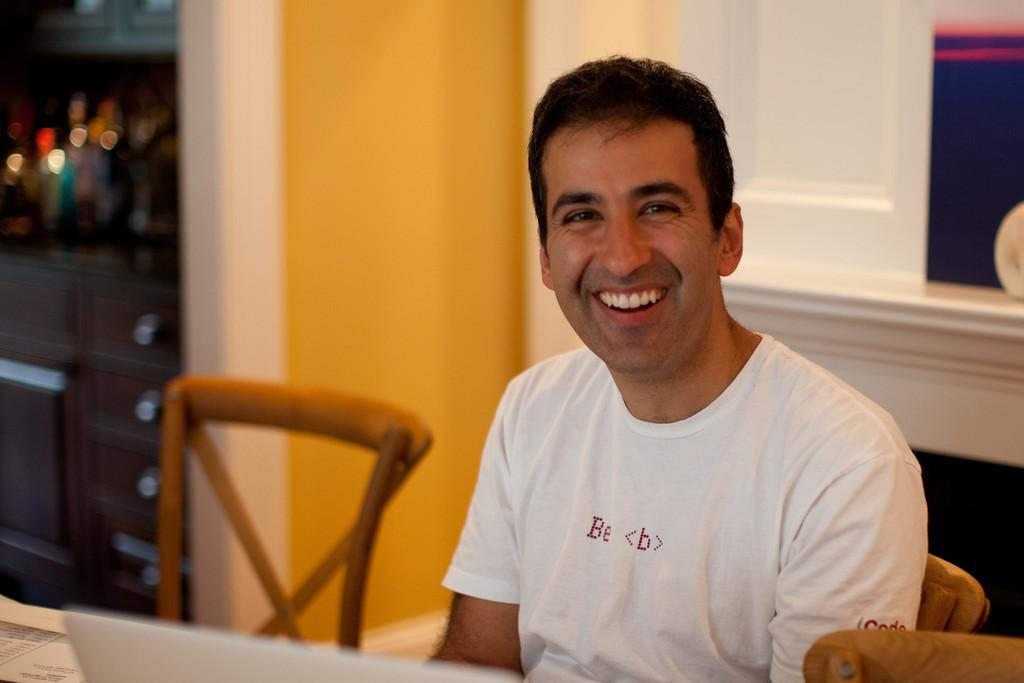What is the main subject of the image? There is a man in the image. What is the man doing in the image? The man is sitting on a chair. How does the man appear to be feeling in the image? The man has a smile on his face, indicating that he may be happy or content. What is the man wearing in the image? The man is wearing a white T-shirt. Are there any other chairs visible in the image? Yes, there is another chair in the image. What type of drug is the man distributing in the image? There is no indication of any drug or distribution activity in the image. The man is simply sitting on a chair with a smile on his face. 